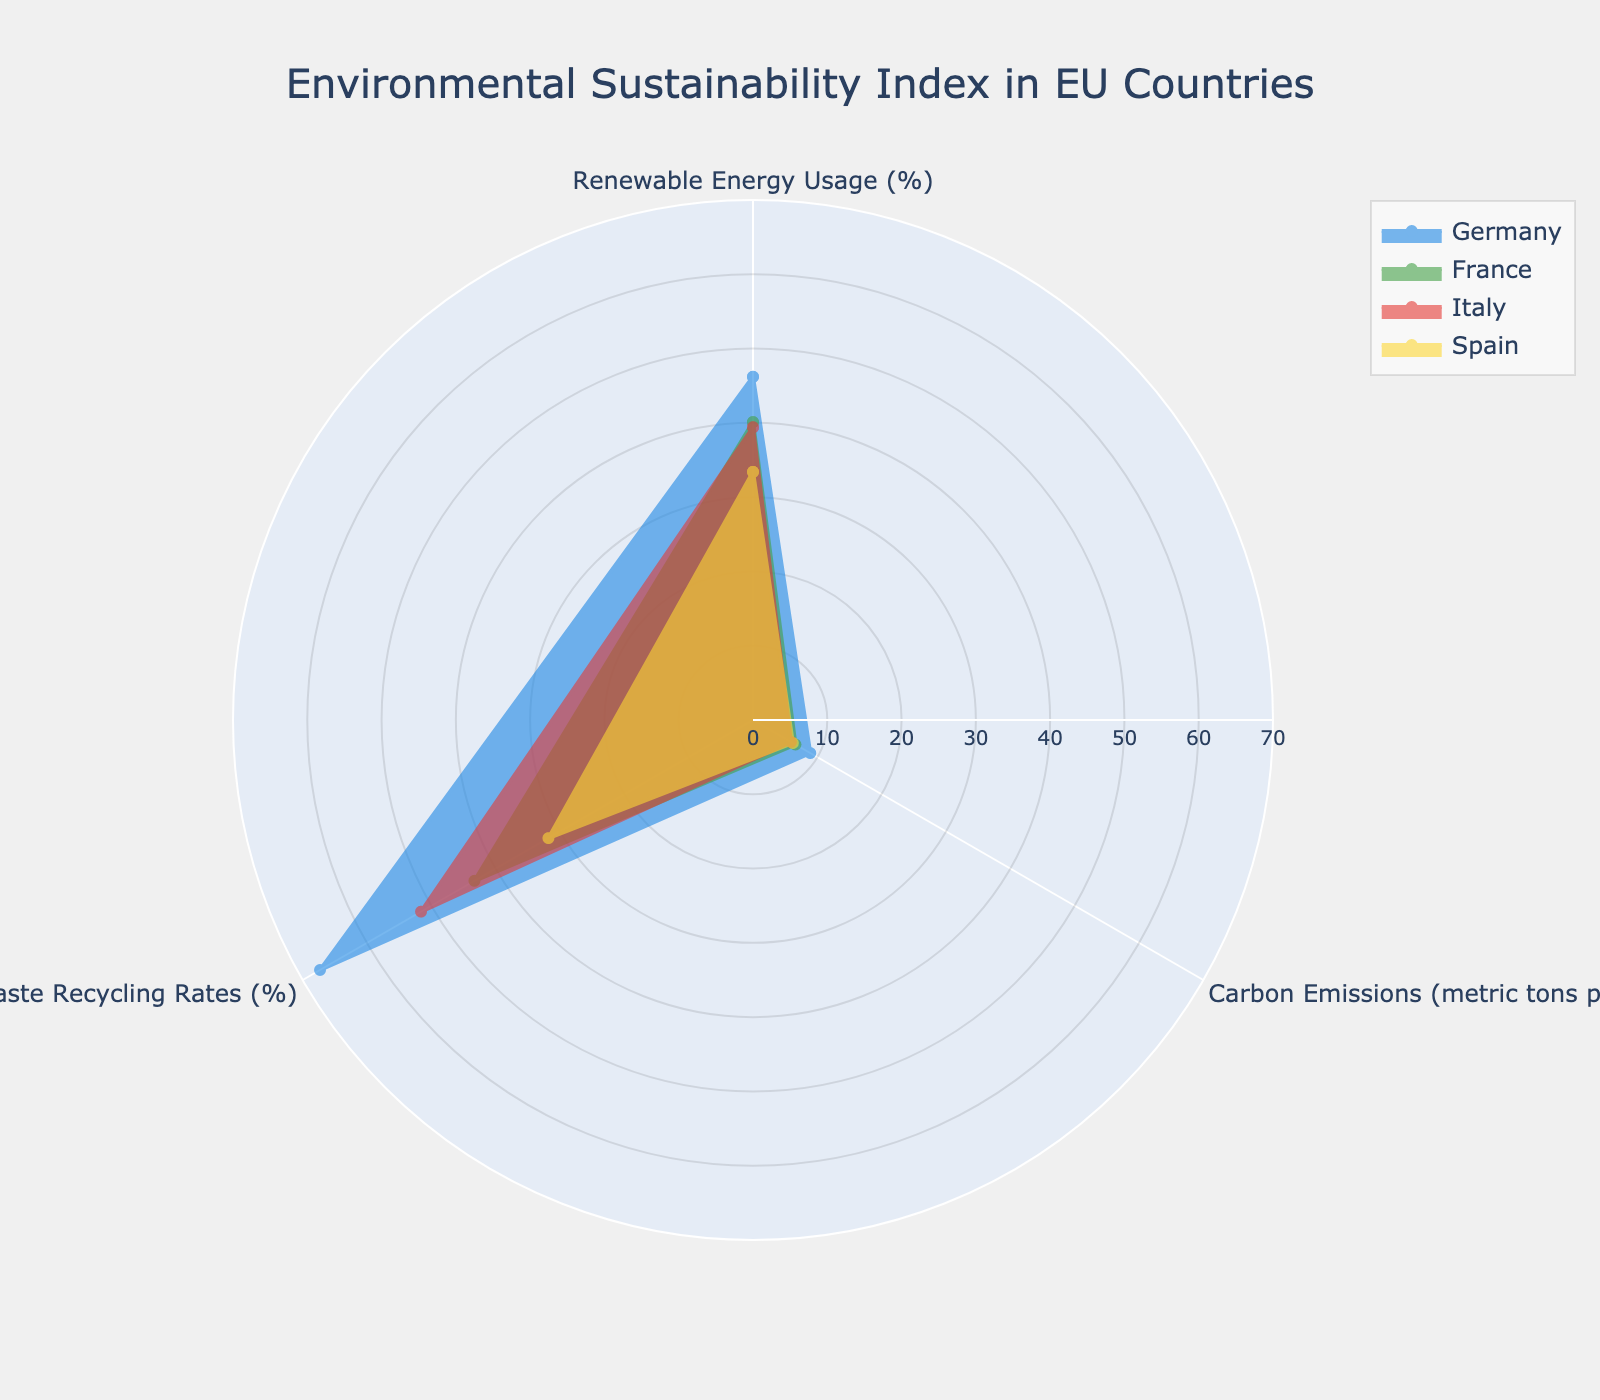What is the title of the radar chart? The title is usually found at the top of the chart. It provides a quick summary of what the chart represents.
Answer: Environmental Sustainability Index in EU Countries Which country has the highest Renewable Energy Usage? Renewable Energy Usage is one of the axes on the radar chart. By comparing the lengths of the sections for Renewable Energy Usage, we can observe which one extends the farthest.
Answer: Germany What is the range of the radial axis in the chart? The radial axis range can be determined by looking at the scale provided along the radial axis. This range is consistent for comparing the different values.
Answer: 0 to 70 Which two countries have the most similar Waste Recycling Rates? By comparing the sections for Waste Recycling Rates for each country, we can identify which ones are closest in length to each other.
Answer: Italy and France What are the three measured aspects in this radar chart? The aspects measured are indicated by the axis labels on the radar chart. In this chart, there are three categories.
Answer: Renewable Energy Usage, Carbon Emissions, Waste Recycling Rates Which country has the lowest Carbon Emissions per capita? Carbon Emissions per capita is one of the axes. The shorter the length of the section for this measure, the lower the emissions.
Answer: Italy Which country has the highest value in Waste Recycling Rates, and what is it? Look for the longest section in the Waste Recycling Rates category to find the highest value.
Answer: Germany, 67.3% Rank the countries from highest to lowest in terms of Renewable Energy Usage. By comparing the sections for Renewable Energy Usage for each country, we can determine their relative positions.
Answer: Germany, France, Italy, Spain Which country shows the greatest disparity between Renewable Energy Usage and Carbon Emissions? To find the disparity, we compare the visual lengths between the Renewable Energy Usage and Carbon Emissions sections for each country. Germany shows a large disparity with high Renewable Energy Usage and relatively high Carbon Emissions.
Answer: Germany What can be inferred about Spain’s environmental sustainability compared to Germany’s? By looking at the radar chart, we can compare the three measured aspects side by side. Spain has lower Renewable Energy Usage and Waste Recycling Rates but also slightly lower Carbon Emissions than Germany. This suggests Spain is less effective in Renewable Energy Usage and Waste Recycling while having comparable Carbon Emissions.
Answer: Spain has lower Renewable Energy and Waste Recycling rates, slightly lower Carbon Emissions 